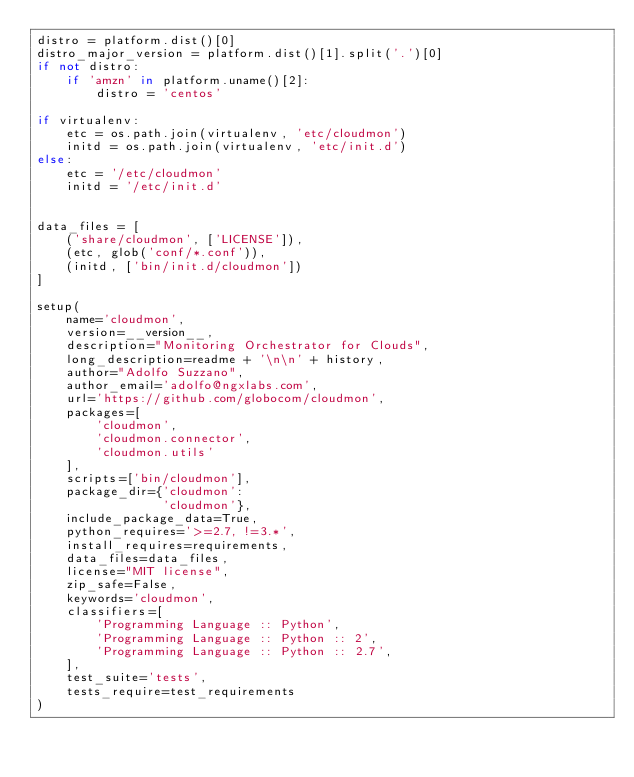Convert code to text. <code><loc_0><loc_0><loc_500><loc_500><_Python_>distro = platform.dist()[0]
distro_major_version = platform.dist()[1].split('.')[0]
if not distro:
    if 'amzn' in platform.uname()[2]:
        distro = 'centos'

if virtualenv:
    etc = os.path.join(virtualenv, 'etc/cloudmon')
    initd = os.path.join(virtualenv, 'etc/init.d')
else:
    etc = '/etc/cloudmon'
    initd = '/etc/init.d'


data_files = [
    ('share/cloudmon', ['LICENSE']),
    (etc, glob('conf/*.conf')),
    (initd, ['bin/init.d/cloudmon'])
]

setup(
    name='cloudmon',
    version=__version__,
    description="Monitoring Orchestrator for Clouds",
    long_description=readme + '\n\n' + history,
    author="Adolfo Suzzano",
    author_email='adolfo@ngxlabs.com',
    url='https://github.com/globocom/cloudmon',
    packages=[
        'cloudmon',
        'cloudmon.connector',
        'cloudmon.utils'
    ],
    scripts=['bin/cloudmon'],
    package_dir={'cloudmon':
                 'cloudmon'},
    include_package_data=True,
    python_requires='>=2.7, !=3.*',
    install_requires=requirements,
    data_files=data_files,
    license="MIT license",
    zip_safe=False,
    keywords='cloudmon',
    classifiers=[
        'Programming Language :: Python',
        'Programming Language :: Python :: 2',
        'Programming Language :: Python :: 2.7',
    ],
    test_suite='tests',
    tests_require=test_requirements
)
</code> 